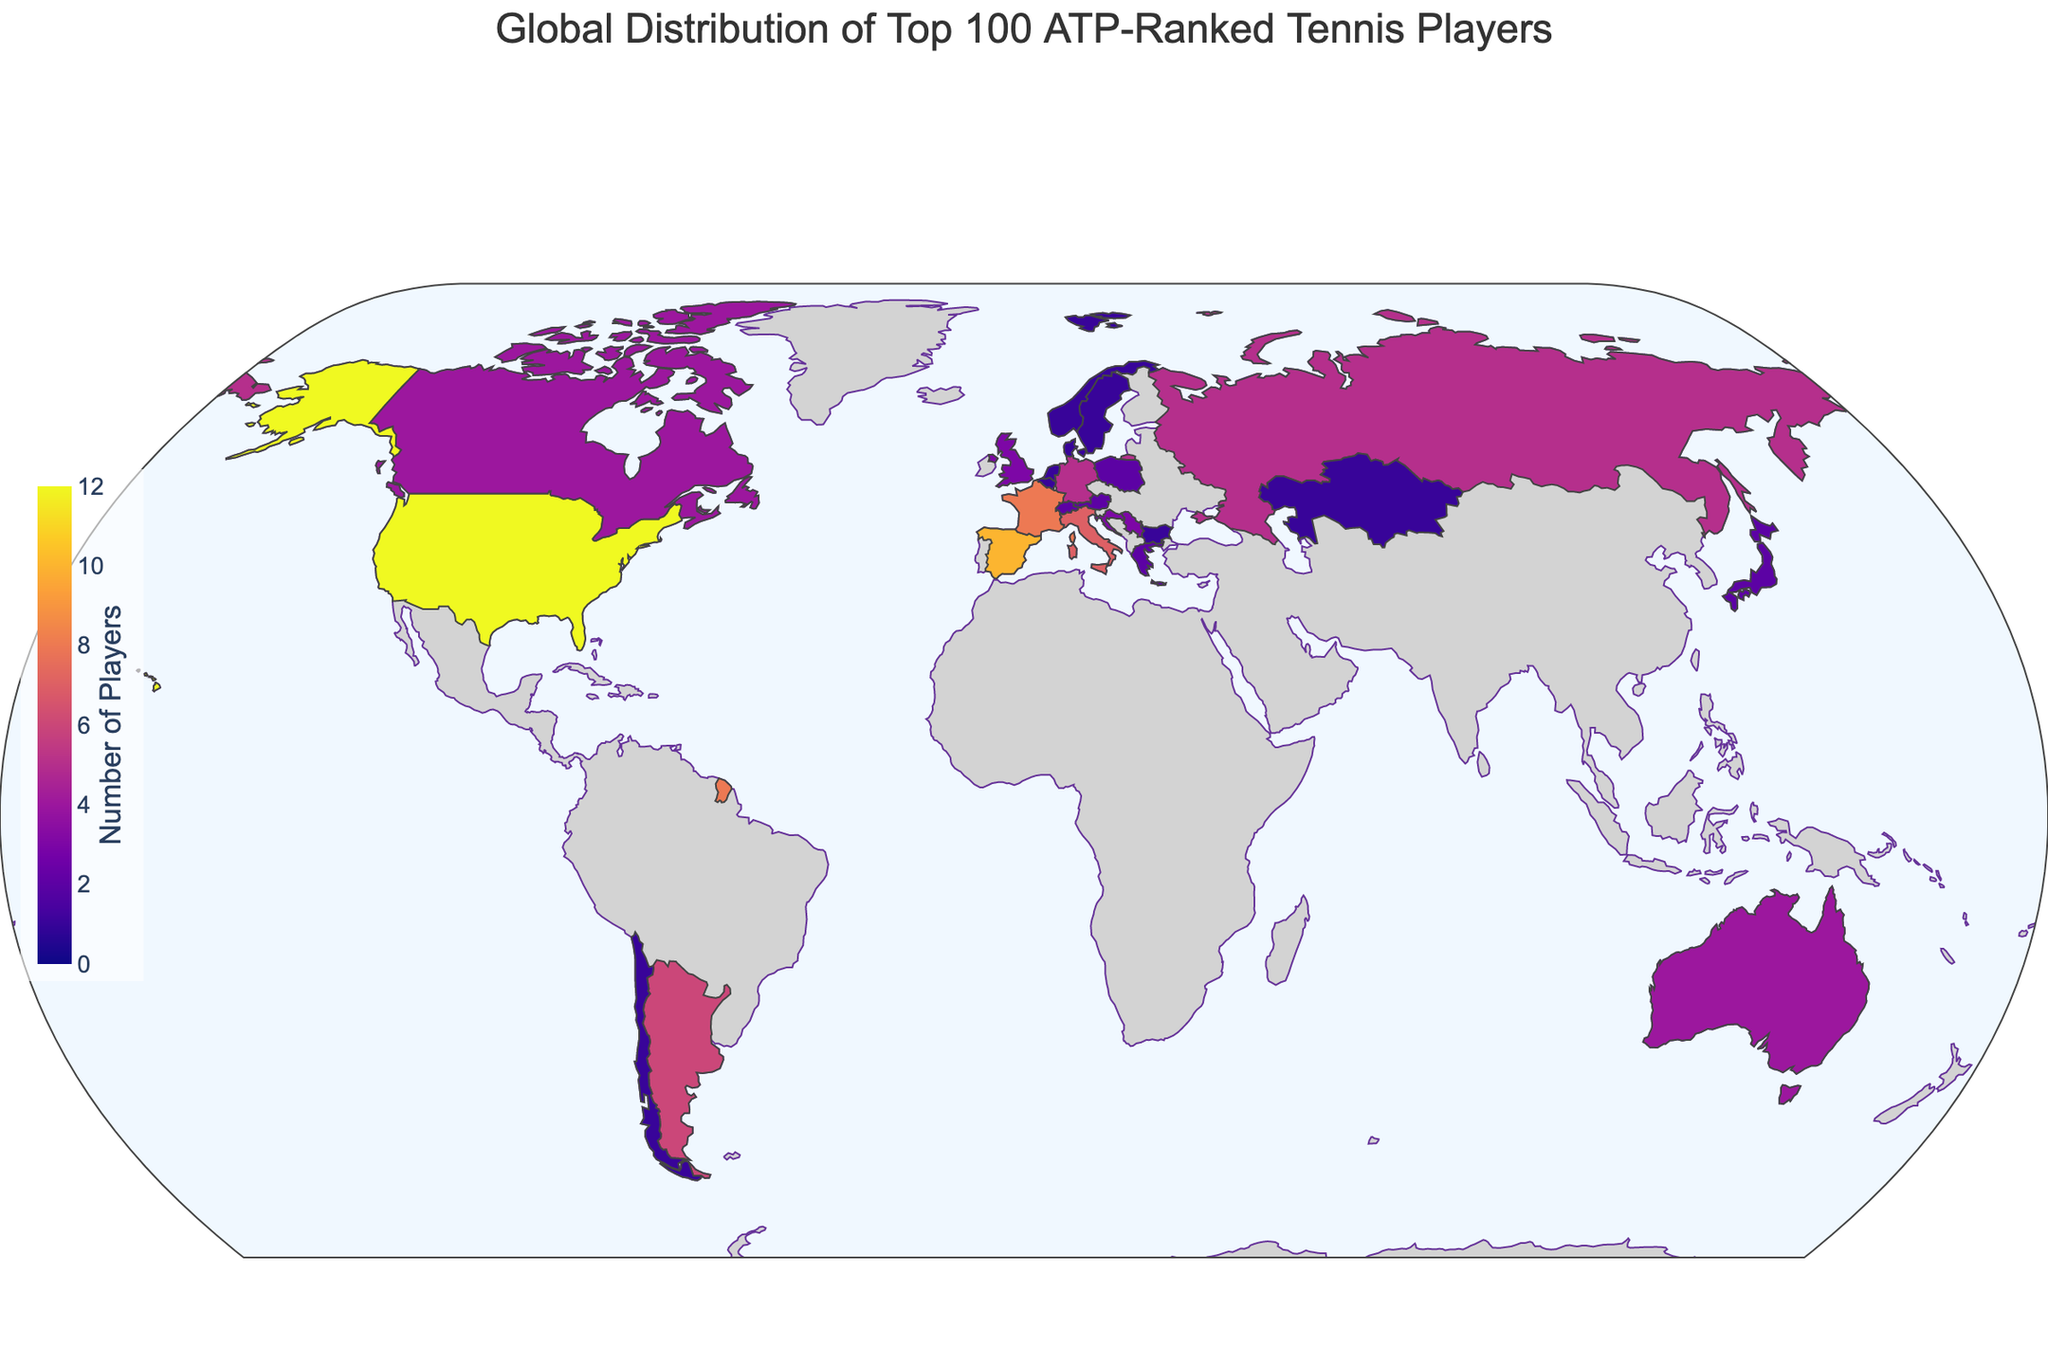What's the title of the figure? The title of a figure is usually found at the top of the plot. In this case, it is clearly indicated in the code used to generate the figure.
Answer: Global Distribution of Top 100 ATP-Ranked Tennis Players Which country has the highest number of top 100 ATP-ranked tennis players? By looking at the color intensity and referring to the data values, we can identify the country with the highest count. The United States has the darkest color, indicating the highest number.
Answer: United States How many countries have exactly one player in the top 100 ATP rankings? To determine this, we need to count all the countries which are shaded the lightest, corresponding to the value of one in the dataset. Norway, Denmark, Bulgaria, Chile, Kazakhstan, Netherlands, Sweden, and Belgium each have one player.
Answer: 8 What is the total number of top 100 ATP-ranked players from European countries? European countries in the list include Spain (10), France (8), Italy (7), Germany (5), Russia (5), Serbia (3), Great Britain (3), Croatia (3), Austria (2), Switzerland (2), Poland (2), Norway (1), Denmark (1), Bulgaria (1), Netherlands (1), and Sweden (1). Summing these numbers gives: 10 + 8 + 7 + 5 + 5 + 3 + 3 + 3 + 2 + 2 + 2 + 1 + 1 + 1 + 1 + 1 = 55
Answer: 55 Compare the number of top 100 ATP-ranked players from North America versus South America. Which continent has more players? North America consists of the United States (12) and Canada (4). South America consists of Argentina (6) and Chile (1). Comparing the sums 12 + 4 = 16 (North America) and 6 + 1 = 7 (South America), North America has more players.
Answer: North America How does the number of top 100 ATP-ranked players from Australia compare to Japan? Both Australia and Japan have marked values in the data. Australia has 4 players and Japan has 2 players, so Australia has more players.
Answer: Australia What is the average number of players for countries having exactly two players in the top 100 ATP rankings? The countries with exactly two players are Japan, Switzerland, Austria, Greece, and Poland. Their combined total is 2 + 2 + 2 + 2 + 2 = 10, divided by the number of these countries, which is 5, giving an average of 10/5 = 2.
Answer: 2 Which countries have more than 5 top 100 ATP-ranked players? From the dataset, the countries with more than five players are United States (12), Spain (10), France (8), Italy (7), and Argentina (6).
Answer: United States, Spain, France, Italy, Argentina What's the combined total of top 100 ATP-ranked players from Italy and Argentina? Italy has 7 and Argentina has 6 players. Adding these numbers gives 7 + 6 = 13.
Answer: 13 